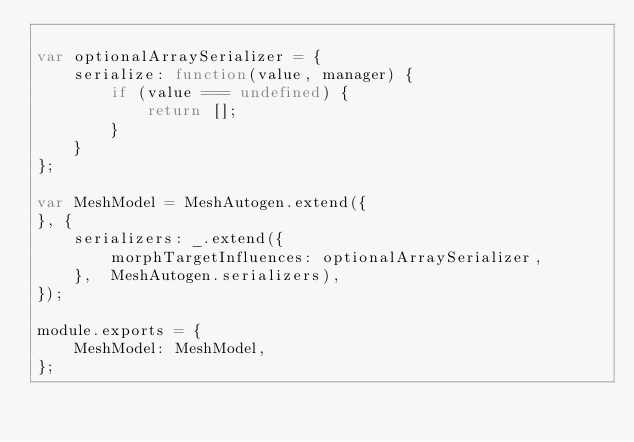Convert code to text. <code><loc_0><loc_0><loc_500><loc_500><_JavaScript_>
var optionalArraySerializer = {
    serialize: function(value, manager) {
        if (value === undefined) {
            return [];
        }
    }
};

var MeshModel = MeshAutogen.extend({
}, {
    serializers: _.extend({
        morphTargetInfluences: optionalArraySerializer,
    },  MeshAutogen.serializers),
});

module.exports = {
    MeshModel: MeshModel,
};
</code> 